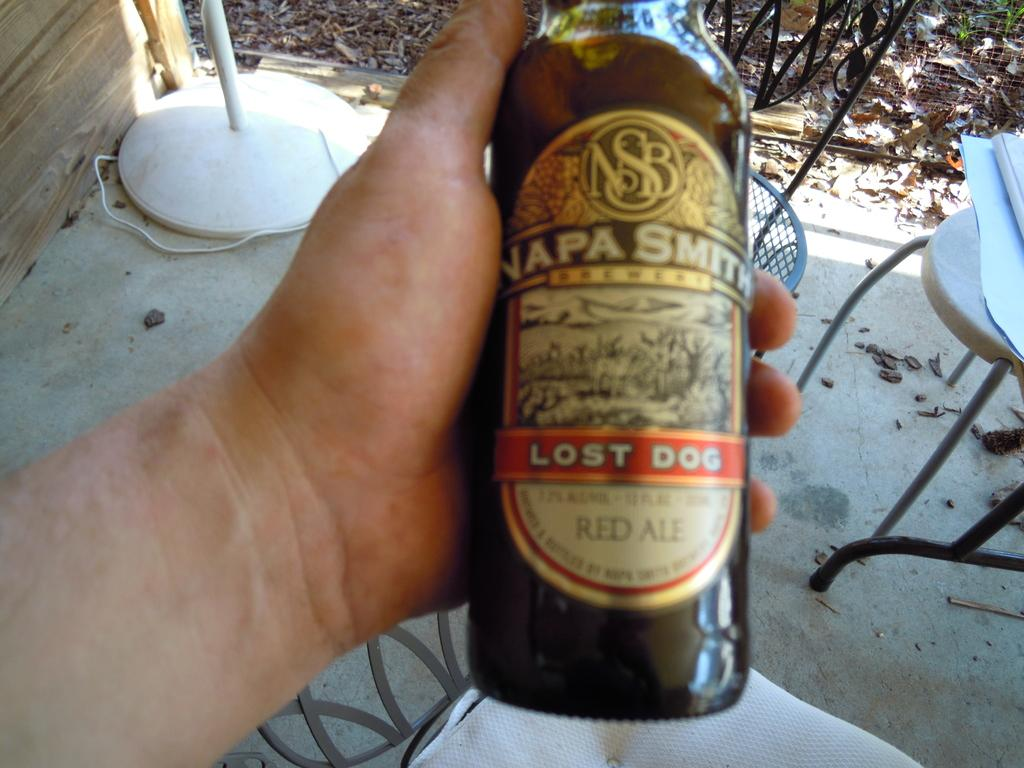<image>
Offer a succinct explanation of the picture presented. a Napa Smith Lost Dog Red Ale in a hand 